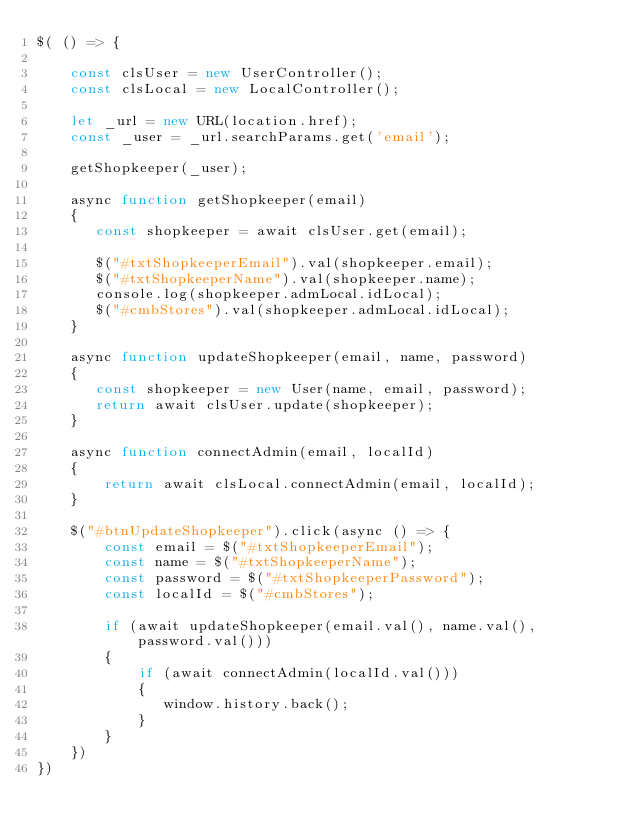<code> <loc_0><loc_0><loc_500><loc_500><_JavaScript_>$( () => {

    const clsUser = new UserController();
    const clsLocal = new LocalController();

    let _url = new URL(location.href);
    const _user = _url.searchParams.get('email');

    getShopkeeper(_user);

    async function getShopkeeper(email)
    {
       const shopkeeper = await clsUser.get(email);

       $("#txtShopkeeperEmail").val(shopkeeper.email);
       $("#txtShopkeeperName").val(shopkeeper.name);
       console.log(shopkeeper.admLocal.idLocal);
       $("#cmbStores").val(shopkeeper.admLocal.idLocal);
    }

    async function updateShopkeeper(email, name, password)
    {
       const shopkeeper = new User(name, email, password);
       return await clsUser.update(shopkeeper);
    }

    async function connectAdmin(email, localId)
    {
        return await clsLocal.connectAdmin(email, localId);
    }

    $("#btnUpdateShopkeeper").click(async () => {
        const email = $("#txtShopkeeperEmail");
        const name = $("#txtShopkeeperName");
        const password = $("#txtShopkeeperPassword");
        const localId = $("#cmbStores");

        if (await updateShopkeeper(email.val(), name.val(), password.val()))
        {
            if (await connectAdmin(localId.val()))
            {
               window.history.back();
            }
        }
    })
})</code> 